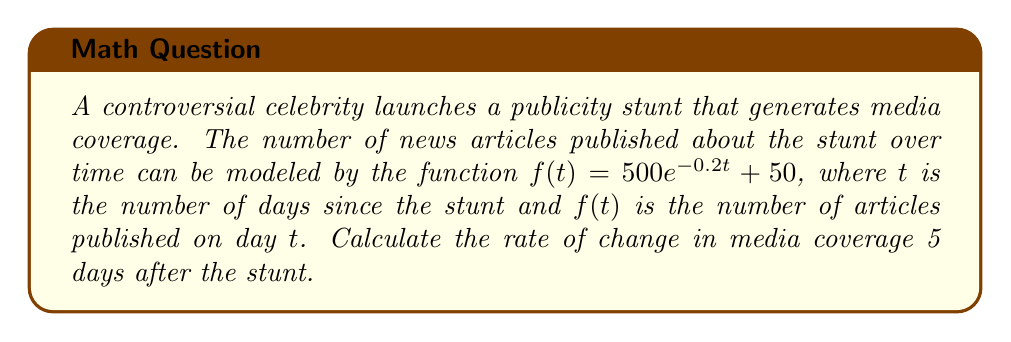Teach me how to tackle this problem. To find the rate of change in media coverage 5 days after the stunt, we need to calculate the derivative of the given function and evaluate it at $t = 5$.

Step 1: Find the derivative of $f(t)$.
$$f'(t) = \frac{d}{dt}(500e^{-0.2t} + 50) = 500 \cdot (-0.2)e^{-0.2t} + 0 = -100e^{-0.2t}$$

Step 2: Evaluate $f'(t)$ at $t = 5$.
$$f'(5) = -100e^{-0.2(5)} = -100e^{-1} \approx -36.79$$

Step 3: Interpret the result.
The negative value indicates that the media coverage is decreasing. The rate of change is approximately -36.79 articles per day, 5 days after the stunt.
Answer: $-100e^{-1} \approx -36.79$ articles/day 